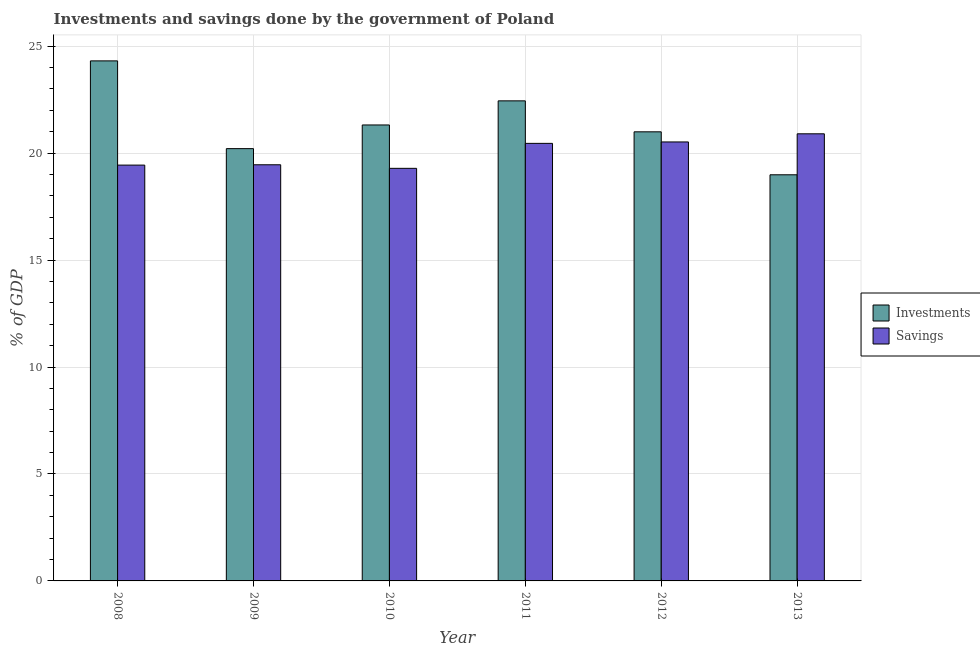How many groups of bars are there?
Keep it short and to the point. 6. Are the number of bars per tick equal to the number of legend labels?
Your response must be concise. Yes. Are the number of bars on each tick of the X-axis equal?
Make the answer very short. Yes. How many bars are there on the 2nd tick from the left?
Ensure brevity in your answer.  2. How many bars are there on the 4th tick from the right?
Provide a short and direct response. 2. What is the savings of government in 2011?
Your answer should be very brief. 20.46. Across all years, what is the maximum savings of government?
Give a very brief answer. 20.9. Across all years, what is the minimum investments of government?
Provide a short and direct response. 18.99. In which year was the investments of government maximum?
Offer a very short reply. 2008. What is the total investments of government in the graph?
Keep it short and to the point. 128.27. What is the difference between the savings of government in 2009 and that in 2010?
Offer a terse response. 0.17. What is the difference between the savings of government in 2009 and the investments of government in 2013?
Provide a short and direct response. -1.45. What is the average investments of government per year?
Your answer should be compact. 21.38. What is the ratio of the savings of government in 2008 to that in 2009?
Offer a very short reply. 1. Is the difference between the savings of government in 2009 and 2012 greater than the difference between the investments of government in 2009 and 2012?
Give a very brief answer. No. What is the difference between the highest and the second highest investments of government?
Ensure brevity in your answer.  1.87. What is the difference between the highest and the lowest savings of government?
Provide a succinct answer. 1.61. In how many years, is the investments of government greater than the average investments of government taken over all years?
Your response must be concise. 2. Is the sum of the investments of government in 2008 and 2011 greater than the maximum savings of government across all years?
Your response must be concise. Yes. What does the 1st bar from the left in 2009 represents?
Offer a terse response. Investments. What does the 1st bar from the right in 2009 represents?
Provide a short and direct response. Savings. How many bars are there?
Make the answer very short. 12. How many years are there in the graph?
Give a very brief answer. 6. What is the difference between two consecutive major ticks on the Y-axis?
Offer a terse response. 5. Does the graph contain any zero values?
Offer a very short reply. No. What is the title of the graph?
Keep it short and to the point. Investments and savings done by the government of Poland. What is the label or title of the X-axis?
Ensure brevity in your answer.  Year. What is the label or title of the Y-axis?
Offer a very short reply. % of GDP. What is the % of GDP in Investments in 2008?
Provide a short and direct response. 24.31. What is the % of GDP of Savings in 2008?
Your response must be concise. 19.44. What is the % of GDP in Investments in 2009?
Make the answer very short. 20.21. What is the % of GDP of Savings in 2009?
Ensure brevity in your answer.  19.46. What is the % of GDP of Investments in 2010?
Ensure brevity in your answer.  21.32. What is the % of GDP of Savings in 2010?
Your response must be concise. 19.29. What is the % of GDP in Investments in 2011?
Your answer should be compact. 22.44. What is the % of GDP of Savings in 2011?
Your answer should be compact. 20.46. What is the % of GDP in Investments in 2012?
Give a very brief answer. 21. What is the % of GDP of Savings in 2012?
Provide a succinct answer. 20.52. What is the % of GDP of Investments in 2013?
Provide a succinct answer. 18.99. What is the % of GDP of Savings in 2013?
Your answer should be very brief. 20.9. Across all years, what is the maximum % of GDP in Investments?
Your response must be concise. 24.31. Across all years, what is the maximum % of GDP of Savings?
Provide a succinct answer. 20.9. Across all years, what is the minimum % of GDP in Investments?
Your answer should be very brief. 18.99. Across all years, what is the minimum % of GDP in Savings?
Keep it short and to the point. 19.29. What is the total % of GDP of Investments in the graph?
Offer a very short reply. 128.27. What is the total % of GDP in Savings in the graph?
Your answer should be compact. 120.07. What is the difference between the % of GDP of Investments in 2008 and that in 2009?
Keep it short and to the point. 4.1. What is the difference between the % of GDP of Savings in 2008 and that in 2009?
Make the answer very short. -0.02. What is the difference between the % of GDP of Investments in 2008 and that in 2010?
Make the answer very short. 3. What is the difference between the % of GDP of Savings in 2008 and that in 2010?
Keep it short and to the point. 0.15. What is the difference between the % of GDP in Investments in 2008 and that in 2011?
Provide a succinct answer. 1.87. What is the difference between the % of GDP of Savings in 2008 and that in 2011?
Ensure brevity in your answer.  -1.02. What is the difference between the % of GDP in Investments in 2008 and that in 2012?
Provide a short and direct response. 3.32. What is the difference between the % of GDP in Savings in 2008 and that in 2012?
Your answer should be very brief. -1.08. What is the difference between the % of GDP of Investments in 2008 and that in 2013?
Offer a very short reply. 5.33. What is the difference between the % of GDP of Savings in 2008 and that in 2013?
Your answer should be compact. -1.46. What is the difference between the % of GDP in Investments in 2009 and that in 2010?
Provide a short and direct response. -1.11. What is the difference between the % of GDP of Savings in 2009 and that in 2010?
Offer a terse response. 0.17. What is the difference between the % of GDP in Investments in 2009 and that in 2011?
Your answer should be compact. -2.23. What is the difference between the % of GDP in Savings in 2009 and that in 2011?
Your answer should be compact. -1. What is the difference between the % of GDP of Investments in 2009 and that in 2012?
Offer a terse response. -0.79. What is the difference between the % of GDP of Savings in 2009 and that in 2012?
Your response must be concise. -1.07. What is the difference between the % of GDP of Investments in 2009 and that in 2013?
Give a very brief answer. 1.22. What is the difference between the % of GDP of Savings in 2009 and that in 2013?
Make the answer very short. -1.45. What is the difference between the % of GDP of Investments in 2010 and that in 2011?
Offer a terse response. -1.13. What is the difference between the % of GDP in Savings in 2010 and that in 2011?
Offer a very short reply. -1.17. What is the difference between the % of GDP of Investments in 2010 and that in 2012?
Provide a succinct answer. 0.32. What is the difference between the % of GDP of Savings in 2010 and that in 2012?
Offer a terse response. -1.23. What is the difference between the % of GDP in Investments in 2010 and that in 2013?
Your response must be concise. 2.33. What is the difference between the % of GDP of Savings in 2010 and that in 2013?
Your response must be concise. -1.61. What is the difference between the % of GDP in Investments in 2011 and that in 2012?
Give a very brief answer. 1.45. What is the difference between the % of GDP of Savings in 2011 and that in 2012?
Ensure brevity in your answer.  -0.07. What is the difference between the % of GDP in Investments in 2011 and that in 2013?
Ensure brevity in your answer.  3.46. What is the difference between the % of GDP of Savings in 2011 and that in 2013?
Keep it short and to the point. -0.45. What is the difference between the % of GDP of Investments in 2012 and that in 2013?
Offer a very short reply. 2.01. What is the difference between the % of GDP in Savings in 2012 and that in 2013?
Offer a very short reply. -0.38. What is the difference between the % of GDP of Investments in 2008 and the % of GDP of Savings in 2009?
Your answer should be very brief. 4.86. What is the difference between the % of GDP in Investments in 2008 and the % of GDP in Savings in 2010?
Offer a terse response. 5.02. What is the difference between the % of GDP in Investments in 2008 and the % of GDP in Savings in 2011?
Make the answer very short. 3.86. What is the difference between the % of GDP of Investments in 2008 and the % of GDP of Savings in 2012?
Ensure brevity in your answer.  3.79. What is the difference between the % of GDP of Investments in 2008 and the % of GDP of Savings in 2013?
Provide a succinct answer. 3.41. What is the difference between the % of GDP of Investments in 2009 and the % of GDP of Savings in 2010?
Provide a succinct answer. 0.92. What is the difference between the % of GDP of Investments in 2009 and the % of GDP of Savings in 2011?
Give a very brief answer. -0.25. What is the difference between the % of GDP in Investments in 2009 and the % of GDP in Savings in 2012?
Your answer should be very brief. -0.31. What is the difference between the % of GDP of Investments in 2009 and the % of GDP of Savings in 2013?
Offer a very short reply. -0.69. What is the difference between the % of GDP in Investments in 2010 and the % of GDP in Savings in 2011?
Give a very brief answer. 0.86. What is the difference between the % of GDP of Investments in 2010 and the % of GDP of Savings in 2012?
Your response must be concise. 0.79. What is the difference between the % of GDP in Investments in 2010 and the % of GDP in Savings in 2013?
Provide a short and direct response. 0.41. What is the difference between the % of GDP of Investments in 2011 and the % of GDP of Savings in 2012?
Ensure brevity in your answer.  1.92. What is the difference between the % of GDP of Investments in 2011 and the % of GDP of Savings in 2013?
Make the answer very short. 1.54. What is the difference between the % of GDP of Investments in 2012 and the % of GDP of Savings in 2013?
Your response must be concise. 0.09. What is the average % of GDP in Investments per year?
Make the answer very short. 21.38. What is the average % of GDP of Savings per year?
Offer a very short reply. 20.01. In the year 2008, what is the difference between the % of GDP in Investments and % of GDP in Savings?
Keep it short and to the point. 4.87. In the year 2009, what is the difference between the % of GDP of Investments and % of GDP of Savings?
Your response must be concise. 0.75. In the year 2010, what is the difference between the % of GDP of Investments and % of GDP of Savings?
Make the answer very short. 2.03. In the year 2011, what is the difference between the % of GDP of Investments and % of GDP of Savings?
Offer a terse response. 1.99. In the year 2012, what is the difference between the % of GDP in Investments and % of GDP in Savings?
Your answer should be very brief. 0.47. In the year 2013, what is the difference between the % of GDP of Investments and % of GDP of Savings?
Make the answer very short. -1.92. What is the ratio of the % of GDP in Investments in 2008 to that in 2009?
Provide a short and direct response. 1.2. What is the ratio of the % of GDP in Investments in 2008 to that in 2010?
Your answer should be compact. 1.14. What is the ratio of the % of GDP in Savings in 2008 to that in 2010?
Ensure brevity in your answer.  1.01. What is the ratio of the % of GDP in Investments in 2008 to that in 2011?
Offer a very short reply. 1.08. What is the ratio of the % of GDP of Savings in 2008 to that in 2011?
Ensure brevity in your answer.  0.95. What is the ratio of the % of GDP in Investments in 2008 to that in 2012?
Keep it short and to the point. 1.16. What is the ratio of the % of GDP in Savings in 2008 to that in 2012?
Keep it short and to the point. 0.95. What is the ratio of the % of GDP of Investments in 2008 to that in 2013?
Give a very brief answer. 1.28. What is the ratio of the % of GDP in Savings in 2008 to that in 2013?
Offer a terse response. 0.93. What is the ratio of the % of GDP of Investments in 2009 to that in 2010?
Give a very brief answer. 0.95. What is the ratio of the % of GDP of Savings in 2009 to that in 2010?
Give a very brief answer. 1.01. What is the ratio of the % of GDP in Investments in 2009 to that in 2011?
Make the answer very short. 0.9. What is the ratio of the % of GDP of Savings in 2009 to that in 2011?
Your answer should be compact. 0.95. What is the ratio of the % of GDP in Investments in 2009 to that in 2012?
Give a very brief answer. 0.96. What is the ratio of the % of GDP in Savings in 2009 to that in 2012?
Your answer should be compact. 0.95. What is the ratio of the % of GDP of Investments in 2009 to that in 2013?
Offer a very short reply. 1.06. What is the ratio of the % of GDP of Savings in 2009 to that in 2013?
Provide a succinct answer. 0.93. What is the ratio of the % of GDP in Investments in 2010 to that in 2011?
Keep it short and to the point. 0.95. What is the ratio of the % of GDP in Savings in 2010 to that in 2011?
Offer a terse response. 0.94. What is the ratio of the % of GDP of Investments in 2010 to that in 2012?
Provide a short and direct response. 1.02. What is the ratio of the % of GDP in Savings in 2010 to that in 2012?
Give a very brief answer. 0.94. What is the ratio of the % of GDP in Investments in 2010 to that in 2013?
Provide a succinct answer. 1.12. What is the ratio of the % of GDP in Savings in 2010 to that in 2013?
Ensure brevity in your answer.  0.92. What is the ratio of the % of GDP in Investments in 2011 to that in 2012?
Your answer should be compact. 1.07. What is the ratio of the % of GDP in Investments in 2011 to that in 2013?
Give a very brief answer. 1.18. What is the ratio of the % of GDP of Savings in 2011 to that in 2013?
Offer a terse response. 0.98. What is the ratio of the % of GDP of Investments in 2012 to that in 2013?
Offer a terse response. 1.11. What is the ratio of the % of GDP in Savings in 2012 to that in 2013?
Ensure brevity in your answer.  0.98. What is the difference between the highest and the second highest % of GDP in Investments?
Your answer should be compact. 1.87. What is the difference between the highest and the second highest % of GDP in Savings?
Ensure brevity in your answer.  0.38. What is the difference between the highest and the lowest % of GDP in Investments?
Provide a short and direct response. 5.33. What is the difference between the highest and the lowest % of GDP in Savings?
Give a very brief answer. 1.61. 